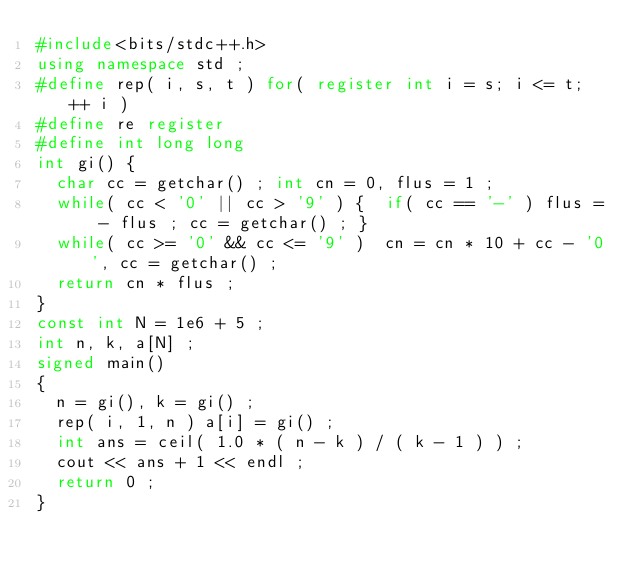<code> <loc_0><loc_0><loc_500><loc_500><_C++_>#include<bits/stdc++.h>
using namespace std ;
#define rep( i, s, t ) for( register int i = s; i <= t; ++ i )
#define re register
#define int long long
int gi() {
	char cc = getchar() ; int cn = 0, flus = 1 ;
	while( cc < '0' || cc > '9' ) {  if( cc == '-' ) flus = - flus ; cc = getchar() ; }
	while( cc >= '0' && cc <= '9' )  cn = cn * 10 + cc - '0', cc = getchar() ;
	return cn * flus ;
}
const int N = 1e6 + 5 ; 
int n, k, a[N] ; 
signed main()
{
	n = gi(), k = gi() ; 
	rep( i, 1, n ) a[i] = gi() ; 
	int ans = ceil( 1.0 * ( n - k ) / ( k - 1 ) ) ;
	cout << ans + 1 << endl ;
	return 0 ;
}</code> 